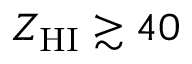Convert formula to latex. <formula><loc_0><loc_0><loc_500><loc_500>Z _ { H I } \gtrsim 4 0</formula> 